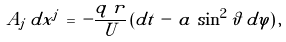<formula> <loc_0><loc_0><loc_500><loc_500>A _ { j } \, d x ^ { j } \, = \, - \frac { q \, r } { U } \, ( d t \, - \, a \, \sin ^ { 2 } \vartheta \, d \varphi ) \, ,</formula> 